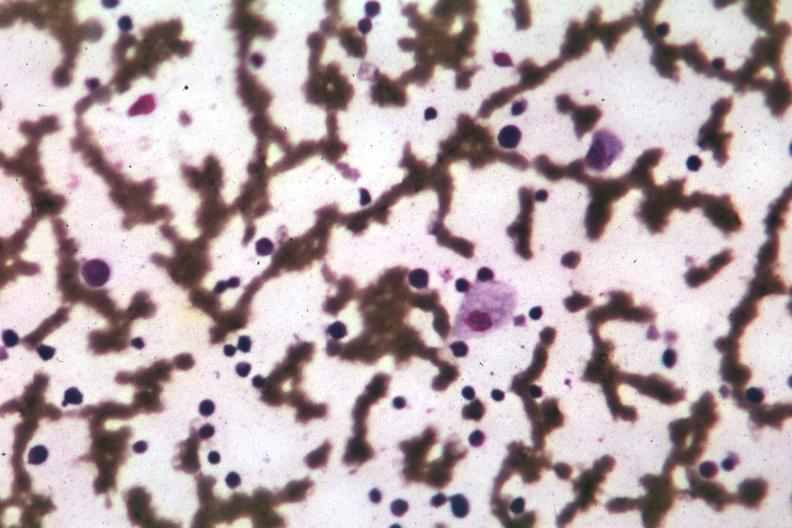s anencephaly and bilateral cleft palate present?
Answer the question using a single word or phrase. No 